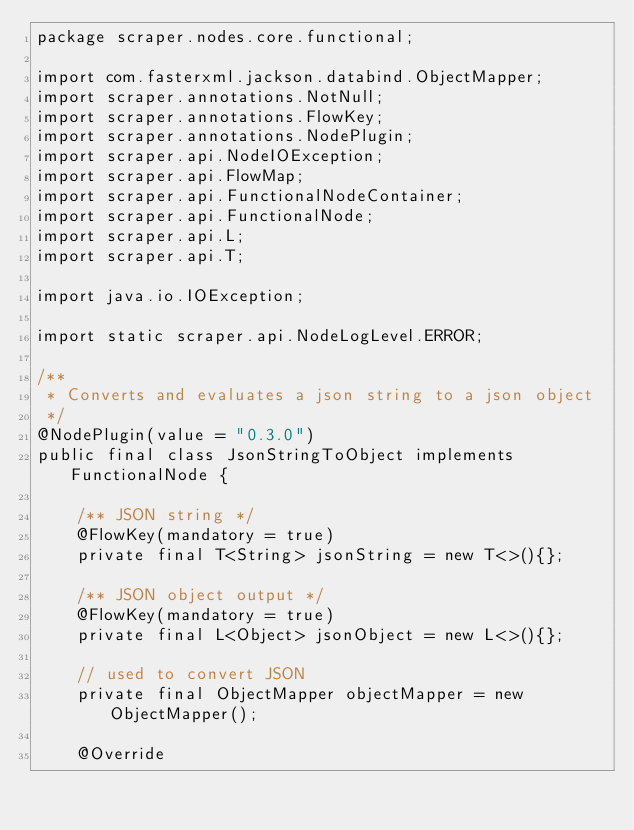<code> <loc_0><loc_0><loc_500><loc_500><_Java_>package scraper.nodes.core.functional;

import com.fasterxml.jackson.databind.ObjectMapper;
import scraper.annotations.NotNull;
import scraper.annotations.FlowKey;
import scraper.annotations.NodePlugin;
import scraper.api.NodeIOException;
import scraper.api.FlowMap;
import scraper.api.FunctionalNodeContainer;
import scraper.api.FunctionalNode;
import scraper.api.L;
import scraper.api.T;

import java.io.IOException;

import static scraper.api.NodeLogLevel.ERROR;

/**
 * Converts and evaluates a json string to a json object
 */
@NodePlugin(value = "0.3.0")
public final class JsonStringToObject implements FunctionalNode {

    /** JSON string */
    @FlowKey(mandatory = true)
    private final T<String> jsonString = new T<>(){};

    /** JSON object output */
    @FlowKey(mandatory = true)
    private final L<Object> jsonObject = new L<>(){};

    // used to convert JSON
    private final ObjectMapper objectMapper = new ObjectMapper();

    @Override</code> 